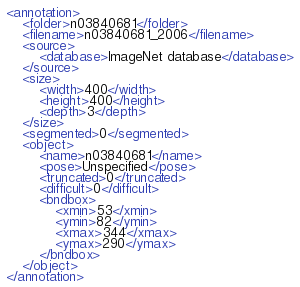Convert code to text. <code><loc_0><loc_0><loc_500><loc_500><_XML_><annotation>
	<folder>n03840681</folder>
	<filename>n03840681_2006</filename>
	<source>
		<database>ImageNet database</database>
	</source>
	<size>
		<width>400</width>
		<height>400</height>
		<depth>3</depth>
	</size>
	<segmented>0</segmented>
	<object>
		<name>n03840681</name>
		<pose>Unspecified</pose>
		<truncated>0</truncated>
		<difficult>0</difficult>
		<bndbox>
			<xmin>53</xmin>
			<ymin>82</ymin>
			<xmax>344</xmax>
			<ymax>290</ymax>
		</bndbox>
	</object>
</annotation></code> 